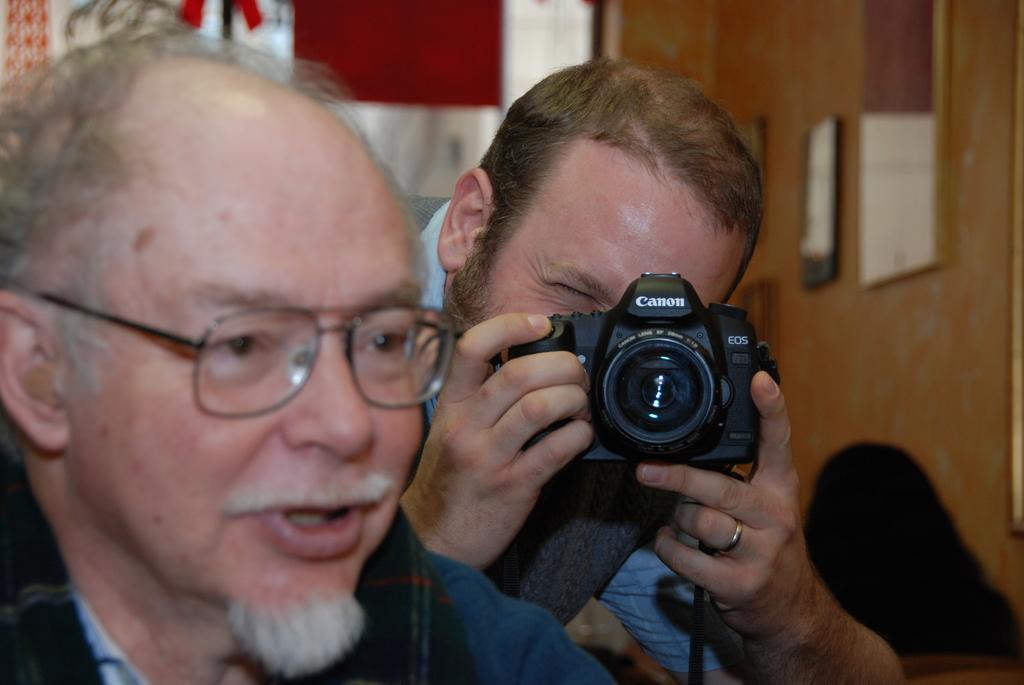Describe this image in one or two sentences. In this picture we can see a man holding a camera and in front of him there is a man who has spectacles. 